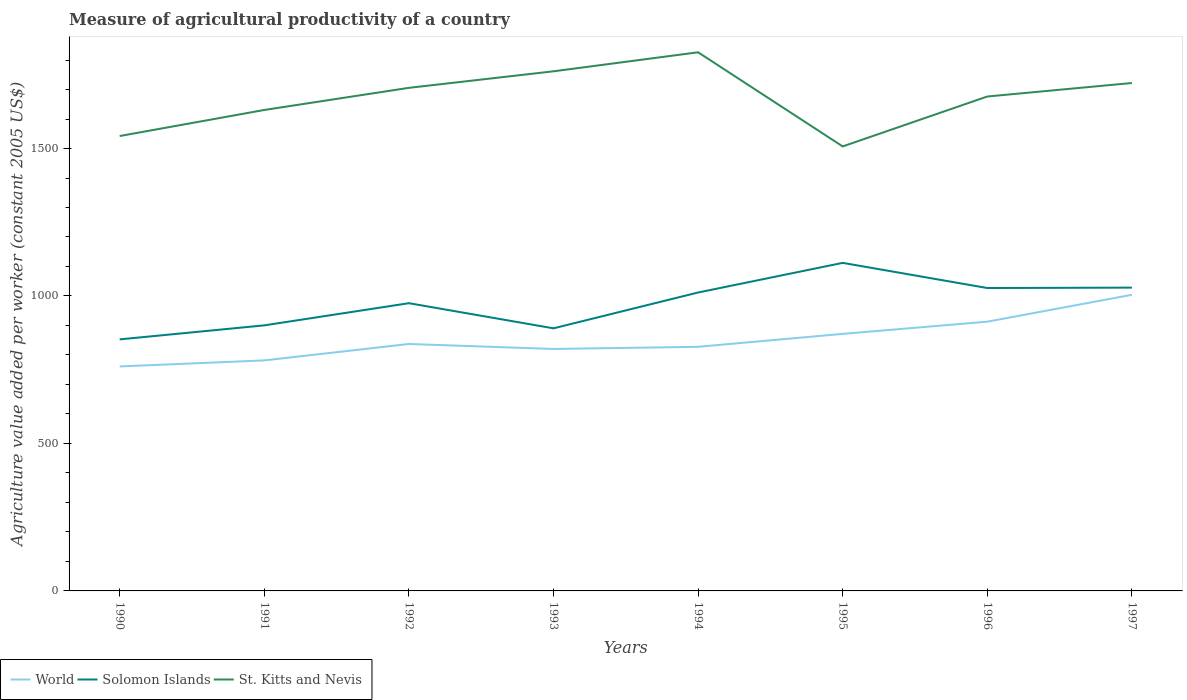How many different coloured lines are there?
Give a very brief answer. 3. Does the line corresponding to St. Kitts and Nevis intersect with the line corresponding to Solomon Islands?
Your answer should be compact. No. Across all years, what is the maximum measure of agricultural productivity in St. Kitts and Nevis?
Offer a terse response. 1507.05. What is the total measure of agricultural productivity in St. Kitts and Nevis in the graph?
Your answer should be very brief. -195.57. What is the difference between the highest and the second highest measure of agricultural productivity in Solomon Islands?
Give a very brief answer. 259.42. How many years are there in the graph?
Offer a terse response. 8. Are the values on the major ticks of Y-axis written in scientific E-notation?
Your answer should be very brief. No. Does the graph contain any zero values?
Offer a terse response. No. Does the graph contain grids?
Your answer should be very brief. No. What is the title of the graph?
Make the answer very short. Measure of agricultural productivity of a country. What is the label or title of the X-axis?
Keep it short and to the point. Years. What is the label or title of the Y-axis?
Keep it short and to the point. Agriculture value added per worker (constant 2005 US$). What is the Agriculture value added per worker (constant 2005 US$) in World in 1990?
Offer a very short reply. 761.04. What is the Agriculture value added per worker (constant 2005 US$) of Solomon Islands in 1990?
Keep it short and to the point. 852.86. What is the Agriculture value added per worker (constant 2005 US$) in St. Kitts and Nevis in 1990?
Your response must be concise. 1542.29. What is the Agriculture value added per worker (constant 2005 US$) of World in 1991?
Give a very brief answer. 781.57. What is the Agriculture value added per worker (constant 2005 US$) of Solomon Islands in 1991?
Your response must be concise. 900.38. What is the Agriculture value added per worker (constant 2005 US$) in St. Kitts and Nevis in 1991?
Offer a terse response. 1630.67. What is the Agriculture value added per worker (constant 2005 US$) in World in 1992?
Offer a very short reply. 837.24. What is the Agriculture value added per worker (constant 2005 US$) of Solomon Islands in 1992?
Your answer should be very brief. 975.54. What is the Agriculture value added per worker (constant 2005 US$) in St. Kitts and Nevis in 1992?
Your response must be concise. 1705.69. What is the Agriculture value added per worker (constant 2005 US$) of World in 1993?
Offer a very short reply. 820.33. What is the Agriculture value added per worker (constant 2005 US$) in Solomon Islands in 1993?
Make the answer very short. 890.33. What is the Agriculture value added per worker (constant 2005 US$) of St. Kitts and Nevis in 1993?
Make the answer very short. 1761.77. What is the Agriculture value added per worker (constant 2005 US$) in World in 1994?
Give a very brief answer. 827.67. What is the Agriculture value added per worker (constant 2005 US$) in Solomon Islands in 1994?
Give a very brief answer. 1011.77. What is the Agriculture value added per worker (constant 2005 US$) in St. Kitts and Nevis in 1994?
Keep it short and to the point. 1826.25. What is the Agriculture value added per worker (constant 2005 US$) in World in 1995?
Your answer should be very brief. 871.52. What is the Agriculture value added per worker (constant 2005 US$) of Solomon Islands in 1995?
Your answer should be compact. 1112.28. What is the Agriculture value added per worker (constant 2005 US$) of St. Kitts and Nevis in 1995?
Your answer should be very brief. 1507.05. What is the Agriculture value added per worker (constant 2005 US$) in World in 1996?
Offer a terse response. 912.86. What is the Agriculture value added per worker (constant 2005 US$) in Solomon Islands in 1996?
Offer a terse response. 1026.97. What is the Agriculture value added per worker (constant 2005 US$) of St. Kitts and Nevis in 1996?
Offer a very short reply. 1676.29. What is the Agriculture value added per worker (constant 2005 US$) of World in 1997?
Offer a terse response. 1003.99. What is the Agriculture value added per worker (constant 2005 US$) in Solomon Islands in 1997?
Give a very brief answer. 1028.33. What is the Agriculture value added per worker (constant 2005 US$) in St. Kitts and Nevis in 1997?
Give a very brief answer. 1722.06. Across all years, what is the maximum Agriculture value added per worker (constant 2005 US$) in World?
Provide a short and direct response. 1003.99. Across all years, what is the maximum Agriculture value added per worker (constant 2005 US$) in Solomon Islands?
Your response must be concise. 1112.28. Across all years, what is the maximum Agriculture value added per worker (constant 2005 US$) in St. Kitts and Nevis?
Your answer should be very brief. 1826.25. Across all years, what is the minimum Agriculture value added per worker (constant 2005 US$) in World?
Your response must be concise. 761.04. Across all years, what is the minimum Agriculture value added per worker (constant 2005 US$) of Solomon Islands?
Make the answer very short. 852.86. Across all years, what is the minimum Agriculture value added per worker (constant 2005 US$) in St. Kitts and Nevis?
Provide a succinct answer. 1507.05. What is the total Agriculture value added per worker (constant 2005 US$) in World in the graph?
Offer a very short reply. 6816.22. What is the total Agriculture value added per worker (constant 2005 US$) in Solomon Islands in the graph?
Provide a succinct answer. 7798.48. What is the total Agriculture value added per worker (constant 2005 US$) in St. Kitts and Nevis in the graph?
Give a very brief answer. 1.34e+04. What is the difference between the Agriculture value added per worker (constant 2005 US$) of World in 1990 and that in 1991?
Provide a succinct answer. -20.53. What is the difference between the Agriculture value added per worker (constant 2005 US$) in Solomon Islands in 1990 and that in 1991?
Keep it short and to the point. -47.52. What is the difference between the Agriculture value added per worker (constant 2005 US$) in St. Kitts and Nevis in 1990 and that in 1991?
Your response must be concise. -88.39. What is the difference between the Agriculture value added per worker (constant 2005 US$) in World in 1990 and that in 1992?
Give a very brief answer. -76.2. What is the difference between the Agriculture value added per worker (constant 2005 US$) in Solomon Islands in 1990 and that in 1992?
Offer a very short reply. -122.68. What is the difference between the Agriculture value added per worker (constant 2005 US$) in St. Kitts and Nevis in 1990 and that in 1992?
Ensure brevity in your answer.  -163.41. What is the difference between the Agriculture value added per worker (constant 2005 US$) of World in 1990 and that in 1993?
Provide a short and direct response. -59.29. What is the difference between the Agriculture value added per worker (constant 2005 US$) in Solomon Islands in 1990 and that in 1993?
Your response must be concise. -37.47. What is the difference between the Agriculture value added per worker (constant 2005 US$) in St. Kitts and Nevis in 1990 and that in 1993?
Provide a short and direct response. -219.48. What is the difference between the Agriculture value added per worker (constant 2005 US$) in World in 1990 and that in 1994?
Give a very brief answer. -66.63. What is the difference between the Agriculture value added per worker (constant 2005 US$) in Solomon Islands in 1990 and that in 1994?
Make the answer very short. -158.91. What is the difference between the Agriculture value added per worker (constant 2005 US$) of St. Kitts and Nevis in 1990 and that in 1994?
Ensure brevity in your answer.  -283.96. What is the difference between the Agriculture value added per worker (constant 2005 US$) of World in 1990 and that in 1995?
Give a very brief answer. -110.48. What is the difference between the Agriculture value added per worker (constant 2005 US$) of Solomon Islands in 1990 and that in 1995?
Provide a short and direct response. -259.42. What is the difference between the Agriculture value added per worker (constant 2005 US$) of St. Kitts and Nevis in 1990 and that in 1995?
Provide a succinct answer. 35.24. What is the difference between the Agriculture value added per worker (constant 2005 US$) in World in 1990 and that in 1996?
Your answer should be compact. -151.82. What is the difference between the Agriculture value added per worker (constant 2005 US$) in Solomon Islands in 1990 and that in 1996?
Provide a short and direct response. -174.11. What is the difference between the Agriculture value added per worker (constant 2005 US$) of St. Kitts and Nevis in 1990 and that in 1996?
Your answer should be very brief. -134.01. What is the difference between the Agriculture value added per worker (constant 2005 US$) in World in 1990 and that in 1997?
Offer a terse response. -242.95. What is the difference between the Agriculture value added per worker (constant 2005 US$) in Solomon Islands in 1990 and that in 1997?
Your response must be concise. -175.47. What is the difference between the Agriculture value added per worker (constant 2005 US$) of St. Kitts and Nevis in 1990 and that in 1997?
Your answer should be very brief. -179.78. What is the difference between the Agriculture value added per worker (constant 2005 US$) of World in 1991 and that in 1992?
Your answer should be very brief. -55.67. What is the difference between the Agriculture value added per worker (constant 2005 US$) in Solomon Islands in 1991 and that in 1992?
Make the answer very short. -75.16. What is the difference between the Agriculture value added per worker (constant 2005 US$) in St. Kitts and Nevis in 1991 and that in 1992?
Make the answer very short. -75.02. What is the difference between the Agriculture value added per worker (constant 2005 US$) of World in 1991 and that in 1993?
Give a very brief answer. -38.76. What is the difference between the Agriculture value added per worker (constant 2005 US$) of Solomon Islands in 1991 and that in 1993?
Provide a succinct answer. 10.05. What is the difference between the Agriculture value added per worker (constant 2005 US$) in St. Kitts and Nevis in 1991 and that in 1993?
Ensure brevity in your answer.  -131.1. What is the difference between the Agriculture value added per worker (constant 2005 US$) of World in 1991 and that in 1994?
Offer a terse response. -46.09. What is the difference between the Agriculture value added per worker (constant 2005 US$) in Solomon Islands in 1991 and that in 1994?
Provide a short and direct response. -111.39. What is the difference between the Agriculture value added per worker (constant 2005 US$) in St. Kitts and Nevis in 1991 and that in 1994?
Your answer should be compact. -195.57. What is the difference between the Agriculture value added per worker (constant 2005 US$) in World in 1991 and that in 1995?
Provide a succinct answer. -89.95. What is the difference between the Agriculture value added per worker (constant 2005 US$) of Solomon Islands in 1991 and that in 1995?
Offer a terse response. -211.9. What is the difference between the Agriculture value added per worker (constant 2005 US$) of St. Kitts and Nevis in 1991 and that in 1995?
Offer a terse response. 123.62. What is the difference between the Agriculture value added per worker (constant 2005 US$) in World in 1991 and that in 1996?
Keep it short and to the point. -131.29. What is the difference between the Agriculture value added per worker (constant 2005 US$) in Solomon Islands in 1991 and that in 1996?
Offer a very short reply. -126.59. What is the difference between the Agriculture value added per worker (constant 2005 US$) in St. Kitts and Nevis in 1991 and that in 1996?
Provide a short and direct response. -45.62. What is the difference between the Agriculture value added per worker (constant 2005 US$) of World in 1991 and that in 1997?
Keep it short and to the point. -222.42. What is the difference between the Agriculture value added per worker (constant 2005 US$) of Solomon Islands in 1991 and that in 1997?
Keep it short and to the point. -127.95. What is the difference between the Agriculture value added per worker (constant 2005 US$) in St. Kitts and Nevis in 1991 and that in 1997?
Offer a very short reply. -91.39. What is the difference between the Agriculture value added per worker (constant 2005 US$) in World in 1992 and that in 1993?
Give a very brief answer. 16.9. What is the difference between the Agriculture value added per worker (constant 2005 US$) in Solomon Islands in 1992 and that in 1993?
Your response must be concise. 85.21. What is the difference between the Agriculture value added per worker (constant 2005 US$) of St. Kitts and Nevis in 1992 and that in 1993?
Your response must be concise. -56.08. What is the difference between the Agriculture value added per worker (constant 2005 US$) in World in 1992 and that in 1994?
Your answer should be compact. 9.57. What is the difference between the Agriculture value added per worker (constant 2005 US$) of Solomon Islands in 1992 and that in 1994?
Your answer should be very brief. -36.23. What is the difference between the Agriculture value added per worker (constant 2005 US$) of St. Kitts and Nevis in 1992 and that in 1994?
Your answer should be compact. -120.55. What is the difference between the Agriculture value added per worker (constant 2005 US$) in World in 1992 and that in 1995?
Offer a very short reply. -34.28. What is the difference between the Agriculture value added per worker (constant 2005 US$) in Solomon Islands in 1992 and that in 1995?
Make the answer very short. -136.74. What is the difference between the Agriculture value added per worker (constant 2005 US$) in St. Kitts and Nevis in 1992 and that in 1995?
Your response must be concise. 198.64. What is the difference between the Agriculture value added per worker (constant 2005 US$) of World in 1992 and that in 1996?
Provide a succinct answer. -75.62. What is the difference between the Agriculture value added per worker (constant 2005 US$) in Solomon Islands in 1992 and that in 1996?
Make the answer very short. -51.43. What is the difference between the Agriculture value added per worker (constant 2005 US$) of St. Kitts and Nevis in 1992 and that in 1996?
Provide a short and direct response. 29.4. What is the difference between the Agriculture value added per worker (constant 2005 US$) in World in 1992 and that in 1997?
Ensure brevity in your answer.  -166.75. What is the difference between the Agriculture value added per worker (constant 2005 US$) in Solomon Islands in 1992 and that in 1997?
Your answer should be compact. -52.79. What is the difference between the Agriculture value added per worker (constant 2005 US$) of St. Kitts and Nevis in 1992 and that in 1997?
Your response must be concise. -16.37. What is the difference between the Agriculture value added per worker (constant 2005 US$) in World in 1993 and that in 1994?
Keep it short and to the point. -7.33. What is the difference between the Agriculture value added per worker (constant 2005 US$) in Solomon Islands in 1993 and that in 1994?
Give a very brief answer. -121.44. What is the difference between the Agriculture value added per worker (constant 2005 US$) in St. Kitts and Nevis in 1993 and that in 1994?
Keep it short and to the point. -64.47. What is the difference between the Agriculture value added per worker (constant 2005 US$) in World in 1993 and that in 1995?
Provide a short and direct response. -51.19. What is the difference between the Agriculture value added per worker (constant 2005 US$) in Solomon Islands in 1993 and that in 1995?
Your response must be concise. -221.95. What is the difference between the Agriculture value added per worker (constant 2005 US$) in St. Kitts and Nevis in 1993 and that in 1995?
Your response must be concise. 254.72. What is the difference between the Agriculture value added per worker (constant 2005 US$) in World in 1993 and that in 1996?
Offer a very short reply. -92.53. What is the difference between the Agriculture value added per worker (constant 2005 US$) of Solomon Islands in 1993 and that in 1996?
Your answer should be compact. -136.64. What is the difference between the Agriculture value added per worker (constant 2005 US$) of St. Kitts and Nevis in 1993 and that in 1996?
Offer a very short reply. 85.48. What is the difference between the Agriculture value added per worker (constant 2005 US$) in World in 1993 and that in 1997?
Make the answer very short. -183.65. What is the difference between the Agriculture value added per worker (constant 2005 US$) of Solomon Islands in 1993 and that in 1997?
Provide a succinct answer. -138. What is the difference between the Agriculture value added per worker (constant 2005 US$) of St. Kitts and Nevis in 1993 and that in 1997?
Your answer should be very brief. 39.71. What is the difference between the Agriculture value added per worker (constant 2005 US$) in World in 1994 and that in 1995?
Ensure brevity in your answer.  -43.86. What is the difference between the Agriculture value added per worker (constant 2005 US$) in Solomon Islands in 1994 and that in 1995?
Ensure brevity in your answer.  -100.51. What is the difference between the Agriculture value added per worker (constant 2005 US$) of St. Kitts and Nevis in 1994 and that in 1995?
Your answer should be very brief. 319.2. What is the difference between the Agriculture value added per worker (constant 2005 US$) in World in 1994 and that in 1996?
Give a very brief answer. -85.2. What is the difference between the Agriculture value added per worker (constant 2005 US$) in Solomon Islands in 1994 and that in 1996?
Offer a terse response. -15.2. What is the difference between the Agriculture value added per worker (constant 2005 US$) of St. Kitts and Nevis in 1994 and that in 1996?
Your answer should be very brief. 149.95. What is the difference between the Agriculture value added per worker (constant 2005 US$) of World in 1994 and that in 1997?
Make the answer very short. -176.32. What is the difference between the Agriculture value added per worker (constant 2005 US$) in Solomon Islands in 1994 and that in 1997?
Give a very brief answer. -16.56. What is the difference between the Agriculture value added per worker (constant 2005 US$) of St. Kitts and Nevis in 1994 and that in 1997?
Your response must be concise. 104.18. What is the difference between the Agriculture value added per worker (constant 2005 US$) of World in 1995 and that in 1996?
Your response must be concise. -41.34. What is the difference between the Agriculture value added per worker (constant 2005 US$) in Solomon Islands in 1995 and that in 1996?
Keep it short and to the point. 85.31. What is the difference between the Agriculture value added per worker (constant 2005 US$) in St. Kitts and Nevis in 1995 and that in 1996?
Provide a short and direct response. -169.24. What is the difference between the Agriculture value added per worker (constant 2005 US$) in World in 1995 and that in 1997?
Offer a very short reply. -132.47. What is the difference between the Agriculture value added per worker (constant 2005 US$) of Solomon Islands in 1995 and that in 1997?
Offer a very short reply. 83.95. What is the difference between the Agriculture value added per worker (constant 2005 US$) in St. Kitts and Nevis in 1995 and that in 1997?
Provide a succinct answer. -215.01. What is the difference between the Agriculture value added per worker (constant 2005 US$) of World in 1996 and that in 1997?
Ensure brevity in your answer.  -91.13. What is the difference between the Agriculture value added per worker (constant 2005 US$) in Solomon Islands in 1996 and that in 1997?
Provide a short and direct response. -1.36. What is the difference between the Agriculture value added per worker (constant 2005 US$) in St. Kitts and Nevis in 1996 and that in 1997?
Provide a succinct answer. -45.77. What is the difference between the Agriculture value added per worker (constant 2005 US$) in World in 1990 and the Agriculture value added per worker (constant 2005 US$) in Solomon Islands in 1991?
Ensure brevity in your answer.  -139.35. What is the difference between the Agriculture value added per worker (constant 2005 US$) in World in 1990 and the Agriculture value added per worker (constant 2005 US$) in St. Kitts and Nevis in 1991?
Offer a terse response. -869.63. What is the difference between the Agriculture value added per worker (constant 2005 US$) of Solomon Islands in 1990 and the Agriculture value added per worker (constant 2005 US$) of St. Kitts and Nevis in 1991?
Keep it short and to the point. -777.81. What is the difference between the Agriculture value added per worker (constant 2005 US$) in World in 1990 and the Agriculture value added per worker (constant 2005 US$) in Solomon Islands in 1992?
Make the answer very short. -214.5. What is the difference between the Agriculture value added per worker (constant 2005 US$) of World in 1990 and the Agriculture value added per worker (constant 2005 US$) of St. Kitts and Nevis in 1992?
Provide a short and direct response. -944.65. What is the difference between the Agriculture value added per worker (constant 2005 US$) in Solomon Islands in 1990 and the Agriculture value added per worker (constant 2005 US$) in St. Kitts and Nevis in 1992?
Your response must be concise. -852.83. What is the difference between the Agriculture value added per worker (constant 2005 US$) of World in 1990 and the Agriculture value added per worker (constant 2005 US$) of Solomon Islands in 1993?
Ensure brevity in your answer.  -129.29. What is the difference between the Agriculture value added per worker (constant 2005 US$) of World in 1990 and the Agriculture value added per worker (constant 2005 US$) of St. Kitts and Nevis in 1993?
Your answer should be very brief. -1000.73. What is the difference between the Agriculture value added per worker (constant 2005 US$) of Solomon Islands in 1990 and the Agriculture value added per worker (constant 2005 US$) of St. Kitts and Nevis in 1993?
Provide a short and direct response. -908.91. What is the difference between the Agriculture value added per worker (constant 2005 US$) of World in 1990 and the Agriculture value added per worker (constant 2005 US$) of Solomon Islands in 1994?
Give a very brief answer. -250.73. What is the difference between the Agriculture value added per worker (constant 2005 US$) in World in 1990 and the Agriculture value added per worker (constant 2005 US$) in St. Kitts and Nevis in 1994?
Provide a succinct answer. -1065.21. What is the difference between the Agriculture value added per worker (constant 2005 US$) of Solomon Islands in 1990 and the Agriculture value added per worker (constant 2005 US$) of St. Kitts and Nevis in 1994?
Ensure brevity in your answer.  -973.38. What is the difference between the Agriculture value added per worker (constant 2005 US$) of World in 1990 and the Agriculture value added per worker (constant 2005 US$) of Solomon Islands in 1995?
Provide a succinct answer. -351.24. What is the difference between the Agriculture value added per worker (constant 2005 US$) of World in 1990 and the Agriculture value added per worker (constant 2005 US$) of St. Kitts and Nevis in 1995?
Give a very brief answer. -746.01. What is the difference between the Agriculture value added per worker (constant 2005 US$) in Solomon Islands in 1990 and the Agriculture value added per worker (constant 2005 US$) in St. Kitts and Nevis in 1995?
Provide a short and direct response. -654.19. What is the difference between the Agriculture value added per worker (constant 2005 US$) of World in 1990 and the Agriculture value added per worker (constant 2005 US$) of Solomon Islands in 1996?
Your answer should be compact. -265.93. What is the difference between the Agriculture value added per worker (constant 2005 US$) of World in 1990 and the Agriculture value added per worker (constant 2005 US$) of St. Kitts and Nevis in 1996?
Keep it short and to the point. -915.25. What is the difference between the Agriculture value added per worker (constant 2005 US$) of Solomon Islands in 1990 and the Agriculture value added per worker (constant 2005 US$) of St. Kitts and Nevis in 1996?
Your answer should be very brief. -823.43. What is the difference between the Agriculture value added per worker (constant 2005 US$) in World in 1990 and the Agriculture value added per worker (constant 2005 US$) in Solomon Islands in 1997?
Provide a succinct answer. -267.29. What is the difference between the Agriculture value added per worker (constant 2005 US$) in World in 1990 and the Agriculture value added per worker (constant 2005 US$) in St. Kitts and Nevis in 1997?
Provide a succinct answer. -961.02. What is the difference between the Agriculture value added per worker (constant 2005 US$) in Solomon Islands in 1990 and the Agriculture value added per worker (constant 2005 US$) in St. Kitts and Nevis in 1997?
Provide a succinct answer. -869.2. What is the difference between the Agriculture value added per worker (constant 2005 US$) in World in 1991 and the Agriculture value added per worker (constant 2005 US$) in Solomon Islands in 1992?
Offer a very short reply. -193.97. What is the difference between the Agriculture value added per worker (constant 2005 US$) of World in 1991 and the Agriculture value added per worker (constant 2005 US$) of St. Kitts and Nevis in 1992?
Ensure brevity in your answer.  -924.12. What is the difference between the Agriculture value added per worker (constant 2005 US$) in Solomon Islands in 1991 and the Agriculture value added per worker (constant 2005 US$) in St. Kitts and Nevis in 1992?
Ensure brevity in your answer.  -805.31. What is the difference between the Agriculture value added per worker (constant 2005 US$) of World in 1991 and the Agriculture value added per worker (constant 2005 US$) of Solomon Islands in 1993?
Your answer should be compact. -108.76. What is the difference between the Agriculture value added per worker (constant 2005 US$) of World in 1991 and the Agriculture value added per worker (constant 2005 US$) of St. Kitts and Nevis in 1993?
Offer a very short reply. -980.2. What is the difference between the Agriculture value added per worker (constant 2005 US$) of Solomon Islands in 1991 and the Agriculture value added per worker (constant 2005 US$) of St. Kitts and Nevis in 1993?
Make the answer very short. -861.39. What is the difference between the Agriculture value added per worker (constant 2005 US$) of World in 1991 and the Agriculture value added per worker (constant 2005 US$) of Solomon Islands in 1994?
Offer a very short reply. -230.2. What is the difference between the Agriculture value added per worker (constant 2005 US$) of World in 1991 and the Agriculture value added per worker (constant 2005 US$) of St. Kitts and Nevis in 1994?
Give a very brief answer. -1044.67. What is the difference between the Agriculture value added per worker (constant 2005 US$) in Solomon Islands in 1991 and the Agriculture value added per worker (constant 2005 US$) in St. Kitts and Nevis in 1994?
Make the answer very short. -925.86. What is the difference between the Agriculture value added per worker (constant 2005 US$) in World in 1991 and the Agriculture value added per worker (constant 2005 US$) in Solomon Islands in 1995?
Your response must be concise. -330.71. What is the difference between the Agriculture value added per worker (constant 2005 US$) of World in 1991 and the Agriculture value added per worker (constant 2005 US$) of St. Kitts and Nevis in 1995?
Your response must be concise. -725.48. What is the difference between the Agriculture value added per worker (constant 2005 US$) in Solomon Islands in 1991 and the Agriculture value added per worker (constant 2005 US$) in St. Kitts and Nevis in 1995?
Your answer should be very brief. -606.66. What is the difference between the Agriculture value added per worker (constant 2005 US$) of World in 1991 and the Agriculture value added per worker (constant 2005 US$) of Solomon Islands in 1996?
Provide a succinct answer. -245.4. What is the difference between the Agriculture value added per worker (constant 2005 US$) in World in 1991 and the Agriculture value added per worker (constant 2005 US$) in St. Kitts and Nevis in 1996?
Ensure brevity in your answer.  -894.72. What is the difference between the Agriculture value added per worker (constant 2005 US$) in Solomon Islands in 1991 and the Agriculture value added per worker (constant 2005 US$) in St. Kitts and Nevis in 1996?
Ensure brevity in your answer.  -775.91. What is the difference between the Agriculture value added per worker (constant 2005 US$) in World in 1991 and the Agriculture value added per worker (constant 2005 US$) in Solomon Islands in 1997?
Offer a very short reply. -246.76. What is the difference between the Agriculture value added per worker (constant 2005 US$) of World in 1991 and the Agriculture value added per worker (constant 2005 US$) of St. Kitts and Nevis in 1997?
Provide a short and direct response. -940.49. What is the difference between the Agriculture value added per worker (constant 2005 US$) in Solomon Islands in 1991 and the Agriculture value added per worker (constant 2005 US$) in St. Kitts and Nevis in 1997?
Ensure brevity in your answer.  -821.68. What is the difference between the Agriculture value added per worker (constant 2005 US$) of World in 1992 and the Agriculture value added per worker (constant 2005 US$) of Solomon Islands in 1993?
Provide a short and direct response. -53.1. What is the difference between the Agriculture value added per worker (constant 2005 US$) in World in 1992 and the Agriculture value added per worker (constant 2005 US$) in St. Kitts and Nevis in 1993?
Provide a succinct answer. -924.53. What is the difference between the Agriculture value added per worker (constant 2005 US$) of Solomon Islands in 1992 and the Agriculture value added per worker (constant 2005 US$) of St. Kitts and Nevis in 1993?
Your answer should be very brief. -786.23. What is the difference between the Agriculture value added per worker (constant 2005 US$) of World in 1992 and the Agriculture value added per worker (constant 2005 US$) of Solomon Islands in 1994?
Ensure brevity in your answer.  -174.53. What is the difference between the Agriculture value added per worker (constant 2005 US$) in World in 1992 and the Agriculture value added per worker (constant 2005 US$) in St. Kitts and Nevis in 1994?
Your answer should be very brief. -989.01. What is the difference between the Agriculture value added per worker (constant 2005 US$) in Solomon Islands in 1992 and the Agriculture value added per worker (constant 2005 US$) in St. Kitts and Nevis in 1994?
Your response must be concise. -850.71. What is the difference between the Agriculture value added per worker (constant 2005 US$) of World in 1992 and the Agriculture value added per worker (constant 2005 US$) of Solomon Islands in 1995?
Make the answer very short. -275.04. What is the difference between the Agriculture value added per worker (constant 2005 US$) in World in 1992 and the Agriculture value added per worker (constant 2005 US$) in St. Kitts and Nevis in 1995?
Make the answer very short. -669.81. What is the difference between the Agriculture value added per worker (constant 2005 US$) of Solomon Islands in 1992 and the Agriculture value added per worker (constant 2005 US$) of St. Kitts and Nevis in 1995?
Provide a short and direct response. -531.51. What is the difference between the Agriculture value added per worker (constant 2005 US$) in World in 1992 and the Agriculture value added per worker (constant 2005 US$) in Solomon Islands in 1996?
Provide a succinct answer. -189.74. What is the difference between the Agriculture value added per worker (constant 2005 US$) in World in 1992 and the Agriculture value added per worker (constant 2005 US$) in St. Kitts and Nevis in 1996?
Your answer should be compact. -839.05. What is the difference between the Agriculture value added per worker (constant 2005 US$) of Solomon Islands in 1992 and the Agriculture value added per worker (constant 2005 US$) of St. Kitts and Nevis in 1996?
Offer a very short reply. -700.75. What is the difference between the Agriculture value added per worker (constant 2005 US$) in World in 1992 and the Agriculture value added per worker (constant 2005 US$) in Solomon Islands in 1997?
Your answer should be compact. -191.1. What is the difference between the Agriculture value added per worker (constant 2005 US$) of World in 1992 and the Agriculture value added per worker (constant 2005 US$) of St. Kitts and Nevis in 1997?
Give a very brief answer. -884.82. What is the difference between the Agriculture value added per worker (constant 2005 US$) in Solomon Islands in 1992 and the Agriculture value added per worker (constant 2005 US$) in St. Kitts and Nevis in 1997?
Your answer should be very brief. -746.52. What is the difference between the Agriculture value added per worker (constant 2005 US$) of World in 1993 and the Agriculture value added per worker (constant 2005 US$) of Solomon Islands in 1994?
Give a very brief answer. -191.44. What is the difference between the Agriculture value added per worker (constant 2005 US$) of World in 1993 and the Agriculture value added per worker (constant 2005 US$) of St. Kitts and Nevis in 1994?
Your response must be concise. -1005.91. What is the difference between the Agriculture value added per worker (constant 2005 US$) of Solomon Islands in 1993 and the Agriculture value added per worker (constant 2005 US$) of St. Kitts and Nevis in 1994?
Provide a succinct answer. -935.91. What is the difference between the Agriculture value added per worker (constant 2005 US$) in World in 1993 and the Agriculture value added per worker (constant 2005 US$) in Solomon Islands in 1995?
Your answer should be compact. -291.95. What is the difference between the Agriculture value added per worker (constant 2005 US$) in World in 1993 and the Agriculture value added per worker (constant 2005 US$) in St. Kitts and Nevis in 1995?
Keep it short and to the point. -686.72. What is the difference between the Agriculture value added per worker (constant 2005 US$) of Solomon Islands in 1993 and the Agriculture value added per worker (constant 2005 US$) of St. Kitts and Nevis in 1995?
Offer a terse response. -616.72. What is the difference between the Agriculture value added per worker (constant 2005 US$) in World in 1993 and the Agriculture value added per worker (constant 2005 US$) in Solomon Islands in 1996?
Your response must be concise. -206.64. What is the difference between the Agriculture value added per worker (constant 2005 US$) of World in 1993 and the Agriculture value added per worker (constant 2005 US$) of St. Kitts and Nevis in 1996?
Give a very brief answer. -855.96. What is the difference between the Agriculture value added per worker (constant 2005 US$) in Solomon Islands in 1993 and the Agriculture value added per worker (constant 2005 US$) in St. Kitts and Nevis in 1996?
Provide a short and direct response. -785.96. What is the difference between the Agriculture value added per worker (constant 2005 US$) in World in 1993 and the Agriculture value added per worker (constant 2005 US$) in Solomon Islands in 1997?
Give a very brief answer. -208. What is the difference between the Agriculture value added per worker (constant 2005 US$) of World in 1993 and the Agriculture value added per worker (constant 2005 US$) of St. Kitts and Nevis in 1997?
Your response must be concise. -901.73. What is the difference between the Agriculture value added per worker (constant 2005 US$) of Solomon Islands in 1993 and the Agriculture value added per worker (constant 2005 US$) of St. Kitts and Nevis in 1997?
Ensure brevity in your answer.  -831.73. What is the difference between the Agriculture value added per worker (constant 2005 US$) of World in 1994 and the Agriculture value added per worker (constant 2005 US$) of Solomon Islands in 1995?
Your response must be concise. -284.61. What is the difference between the Agriculture value added per worker (constant 2005 US$) in World in 1994 and the Agriculture value added per worker (constant 2005 US$) in St. Kitts and Nevis in 1995?
Your answer should be very brief. -679.38. What is the difference between the Agriculture value added per worker (constant 2005 US$) in Solomon Islands in 1994 and the Agriculture value added per worker (constant 2005 US$) in St. Kitts and Nevis in 1995?
Make the answer very short. -495.28. What is the difference between the Agriculture value added per worker (constant 2005 US$) in World in 1994 and the Agriculture value added per worker (constant 2005 US$) in Solomon Islands in 1996?
Your answer should be compact. -199.31. What is the difference between the Agriculture value added per worker (constant 2005 US$) in World in 1994 and the Agriculture value added per worker (constant 2005 US$) in St. Kitts and Nevis in 1996?
Ensure brevity in your answer.  -848.63. What is the difference between the Agriculture value added per worker (constant 2005 US$) in Solomon Islands in 1994 and the Agriculture value added per worker (constant 2005 US$) in St. Kitts and Nevis in 1996?
Make the answer very short. -664.52. What is the difference between the Agriculture value added per worker (constant 2005 US$) in World in 1994 and the Agriculture value added per worker (constant 2005 US$) in Solomon Islands in 1997?
Make the answer very short. -200.67. What is the difference between the Agriculture value added per worker (constant 2005 US$) in World in 1994 and the Agriculture value added per worker (constant 2005 US$) in St. Kitts and Nevis in 1997?
Your response must be concise. -894.4. What is the difference between the Agriculture value added per worker (constant 2005 US$) of Solomon Islands in 1994 and the Agriculture value added per worker (constant 2005 US$) of St. Kitts and Nevis in 1997?
Your answer should be compact. -710.29. What is the difference between the Agriculture value added per worker (constant 2005 US$) in World in 1995 and the Agriculture value added per worker (constant 2005 US$) in Solomon Islands in 1996?
Provide a succinct answer. -155.45. What is the difference between the Agriculture value added per worker (constant 2005 US$) in World in 1995 and the Agriculture value added per worker (constant 2005 US$) in St. Kitts and Nevis in 1996?
Offer a terse response. -804.77. What is the difference between the Agriculture value added per worker (constant 2005 US$) in Solomon Islands in 1995 and the Agriculture value added per worker (constant 2005 US$) in St. Kitts and Nevis in 1996?
Give a very brief answer. -564.01. What is the difference between the Agriculture value added per worker (constant 2005 US$) in World in 1995 and the Agriculture value added per worker (constant 2005 US$) in Solomon Islands in 1997?
Make the answer very short. -156.81. What is the difference between the Agriculture value added per worker (constant 2005 US$) in World in 1995 and the Agriculture value added per worker (constant 2005 US$) in St. Kitts and Nevis in 1997?
Provide a succinct answer. -850.54. What is the difference between the Agriculture value added per worker (constant 2005 US$) of Solomon Islands in 1995 and the Agriculture value added per worker (constant 2005 US$) of St. Kitts and Nevis in 1997?
Offer a very short reply. -609.78. What is the difference between the Agriculture value added per worker (constant 2005 US$) in World in 1996 and the Agriculture value added per worker (constant 2005 US$) in Solomon Islands in 1997?
Keep it short and to the point. -115.47. What is the difference between the Agriculture value added per worker (constant 2005 US$) in World in 1996 and the Agriculture value added per worker (constant 2005 US$) in St. Kitts and Nevis in 1997?
Give a very brief answer. -809.2. What is the difference between the Agriculture value added per worker (constant 2005 US$) of Solomon Islands in 1996 and the Agriculture value added per worker (constant 2005 US$) of St. Kitts and Nevis in 1997?
Make the answer very short. -695.09. What is the average Agriculture value added per worker (constant 2005 US$) in World per year?
Provide a succinct answer. 852.03. What is the average Agriculture value added per worker (constant 2005 US$) in Solomon Islands per year?
Give a very brief answer. 974.81. What is the average Agriculture value added per worker (constant 2005 US$) in St. Kitts and Nevis per year?
Offer a terse response. 1671.51. In the year 1990, what is the difference between the Agriculture value added per worker (constant 2005 US$) in World and Agriculture value added per worker (constant 2005 US$) in Solomon Islands?
Make the answer very short. -91.82. In the year 1990, what is the difference between the Agriculture value added per worker (constant 2005 US$) of World and Agriculture value added per worker (constant 2005 US$) of St. Kitts and Nevis?
Your answer should be compact. -781.25. In the year 1990, what is the difference between the Agriculture value added per worker (constant 2005 US$) of Solomon Islands and Agriculture value added per worker (constant 2005 US$) of St. Kitts and Nevis?
Provide a short and direct response. -689.42. In the year 1991, what is the difference between the Agriculture value added per worker (constant 2005 US$) in World and Agriculture value added per worker (constant 2005 US$) in Solomon Islands?
Provide a succinct answer. -118.81. In the year 1991, what is the difference between the Agriculture value added per worker (constant 2005 US$) of World and Agriculture value added per worker (constant 2005 US$) of St. Kitts and Nevis?
Give a very brief answer. -849.1. In the year 1991, what is the difference between the Agriculture value added per worker (constant 2005 US$) in Solomon Islands and Agriculture value added per worker (constant 2005 US$) in St. Kitts and Nevis?
Provide a short and direct response. -730.29. In the year 1992, what is the difference between the Agriculture value added per worker (constant 2005 US$) of World and Agriculture value added per worker (constant 2005 US$) of Solomon Islands?
Provide a short and direct response. -138.3. In the year 1992, what is the difference between the Agriculture value added per worker (constant 2005 US$) of World and Agriculture value added per worker (constant 2005 US$) of St. Kitts and Nevis?
Make the answer very short. -868.46. In the year 1992, what is the difference between the Agriculture value added per worker (constant 2005 US$) of Solomon Islands and Agriculture value added per worker (constant 2005 US$) of St. Kitts and Nevis?
Provide a succinct answer. -730.15. In the year 1993, what is the difference between the Agriculture value added per worker (constant 2005 US$) in World and Agriculture value added per worker (constant 2005 US$) in Solomon Islands?
Offer a terse response. -70. In the year 1993, what is the difference between the Agriculture value added per worker (constant 2005 US$) of World and Agriculture value added per worker (constant 2005 US$) of St. Kitts and Nevis?
Offer a very short reply. -941.44. In the year 1993, what is the difference between the Agriculture value added per worker (constant 2005 US$) in Solomon Islands and Agriculture value added per worker (constant 2005 US$) in St. Kitts and Nevis?
Your response must be concise. -871.44. In the year 1994, what is the difference between the Agriculture value added per worker (constant 2005 US$) of World and Agriculture value added per worker (constant 2005 US$) of Solomon Islands?
Provide a short and direct response. -184.1. In the year 1994, what is the difference between the Agriculture value added per worker (constant 2005 US$) of World and Agriculture value added per worker (constant 2005 US$) of St. Kitts and Nevis?
Your answer should be compact. -998.58. In the year 1994, what is the difference between the Agriculture value added per worker (constant 2005 US$) of Solomon Islands and Agriculture value added per worker (constant 2005 US$) of St. Kitts and Nevis?
Provide a succinct answer. -814.47. In the year 1995, what is the difference between the Agriculture value added per worker (constant 2005 US$) in World and Agriculture value added per worker (constant 2005 US$) in Solomon Islands?
Your response must be concise. -240.76. In the year 1995, what is the difference between the Agriculture value added per worker (constant 2005 US$) of World and Agriculture value added per worker (constant 2005 US$) of St. Kitts and Nevis?
Keep it short and to the point. -635.53. In the year 1995, what is the difference between the Agriculture value added per worker (constant 2005 US$) in Solomon Islands and Agriculture value added per worker (constant 2005 US$) in St. Kitts and Nevis?
Give a very brief answer. -394.77. In the year 1996, what is the difference between the Agriculture value added per worker (constant 2005 US$) of World and Agriculture value added per worker (constant 2005 US$) of Solomon Islands?
Ensure brevity in your answer.  -114.11. In the year 1996, what is the difference between the Agriculture value added per worker (constant 2005 US$) in World and Agriculture value added per worker (constant 2005 US$) in St. Kitts and Nevis?
Give a very brief answer. -763.43. In the year 1996, what is the difference between the Agriculture value added per worker (constant 2005 US$) in Solomon Islands and Agriculture value added per worker (constant 2005 US$) in St. Kitts and Nevis?
Offer a very short reply. -649.32. In the year 1997, what is the difference between the Agriculture value added per worker (constant 2005 US$) in World and Agriculture value added per worker (constant 2005 US$) in Solomon Islands?
Your answer should be very brief. -24.35. In the year 1997, what is the difference between the Agriculture value added per worker (constant 2005 US$) of World and Agriculture value added per worker (constant 2005 US$) of St. Kitts and Nevis?
Provide a succinct answer. -718.07. In the year 1997, what is the difference between the Agriculture value added per worker (constant 2005 US$) of Solomon Islands and Agriculture value added per worker (constant 2005 US$) of St. Kitts and Nevis?
Ensure brevity in your answer.  -693.73. What is the ratio of the Agriculture value added per worker (constant 2005 US$) of World in 1990 to that in 1991?
Make the answer very short. 0.97. What is the ratio of the Agriculture value added per worker (constant 2005 US$) in Solomon Islands in 1990 to that in 1991?
Offer a very short reply. 0.95. What is the ratio of the Agriculture value added per worker (constant 2005 US$) of St. Kitts and Nevis in 1990 to that in 1991?
Your answer should be compact. 0.95. What is the ratio of the Agriculture value added per worker (constant 2005 US$) of World in 1990 to that in 1992?
Give a very brief answer. 0.91. What is the ratio of the Agriculture value added per worker (constant 2005 US$) of Solomon Islands in 1990 to that in 1992?
Keep it short and to the point. 0.87. What is the ratio of the Agriculture value added per worker (constant 2005 US$) in St. Kitts and Nevis in 1990 to that in 1992?
Provide a succinct answer. 0.9. What is the ratio of the Agriculture value added per worker (constant 2005 US$) of World in 1990 to that in 1993?
Offer a very short reply. 0.93. What is the ratio of the Agriculture value added per worker (constant 2005 US$) in Solomon Islands in 1990 to that in 1993?
Keep it short and to the point. 0.96. What is the ratio of the Agriculture value added per worker (constant 2005 US$) of St. Kitts and Nevis in 1990 to that in 1993?
Your answer should be compact. 0.88. What is the ratio of the Agriculture value added per worker (constant 2005 US$) of World in 1990 to that in 1994?
Offer a very short reply. 0.92. What is the ratio of the Agriculture value added per worker (constant 2005 US$) of Solomon Islands in 1990 to that in 1994?
Make the answer very short. 0.84. What is the ratio of the Agriculture value added per worker (constant 2005 US$) in St. Kitts and Nevis in 1990 to that in 1994?
Your answer should be very brief. 0.84. What is the ratio of the Agriculture value added per worker (constant 2005 US$) in World in 1990 to that in 1995?
Make the answer very short. 0.87. What is the ratio of the Agriculture value added per worker (constant 2005 US$) in Solomon Islands in 1990 to that in 1995?
Offer a very short reply. 0.77. What is the ratio of the Agriculture value added per worker (constant 2005 US$) in St. Kitts and Nevis in 1990 to that in 1995?
Give a very brief answer. 1.02. What is the ratio of the Agriculture value added per worker (constant 2005 US$) in World in 1990 to that in 1996?
Your answer should be very brief. 0.83. What is the ratio of the Agriculture value added per worker (constant 2005 US$) of Solomon Islands in 1990 to that in 1996?
Keep it short and to the point. 0.83. What is the ratio of the Agriculture value added per worker (constant 2005 US$) of St. Kitts and Nevis in 1990 to that in 1996?
Keep it short and to the point. 0.92. What is the ratio of the Agriculture value added per worker (constant 2005 US$) of World in 1990 to that in 1997?
Offer a terse response. 0.76. What is the ratio of the Agriculture value added per worker (constant 2005 US$) of Solomon Islands in 1990 to that in 1997?
Ensure brevity in your answer.  0.83. What is the ratio of the Agriculture value added per worker (constant 2005 US$) in St. Kitts and Nevis in 1990 to that in 1997?
Make the answer very short. 0.9. What is the ratio of the Agriculture value added per worker (constant 2005 US$) of World in 1991 to that in 1992?
Provide a short and direct response. 0.93. What is the ratio of the Agriculture value added per worker (constant 2005 US$) of Solomon Islands in 1991 to that in 1992?
Your answer should be compact. 0.92. What is the ratio of the Agriculture value added per worker (constant 2005 US$) of St. Kitts and Nevis in 1991 to that in 1992?
Offer a terse response. 0.96. What is the ratio of the Agriculture value added per worker (constant 2005 US$) of World in 1991 to that in 1993?
Keep it short and to the point. 0.95. What is the ratio of the Agriculture value added per worker (constant 2005 US$) in Solomon Islands in 1991 to that in 1993?
Offer a terse response. 1.01. What is the ratio of the Agriculture value added per worker (constant 2005 US$) of St. Kitts and Nevis in 1991 to that in 1993?
Ensure brevity in your answer.  0.93. What is the ratio of the Agriculture value added per worker (constant 2005 US$) of World in 1991 to that in 1994?
Provide a succinct answer. 0.94. What is the ratio of the Agriculture value added per worker (constant 2005 US$) of Solomon Islands in 1991 to that in 1994?
Your answer should be compact. 0.89. What is the ratio of the Agriculture value added per worker (constant 2005 US$) in St. Kitts and Nevis in 1991 to that in 1994?
Your response must be concise. 0.89. What is the ratio of the Agriculture value added per worker (constant 2005 US$) of World in 1991 to that in 1995?
Your answer should be very brief. 0.9. What is the ratio of the Agriculture value added per worker (constant 2005 US$) of Solomon Islands in 1991 to that in 1995?
Give a very brief answer. 0.81. What is the ratio of the Agriculture value added per worker (constant 2005 US$) in St. Kitts and Nevis in 1991 to that in 1995?
Ensure brevity in your answer.  1.08. What is the ratio of the Agriculture value added per worker (constant 2005 US$) in World in 1991 to that in 1996?
Provide a succinct answer. 0.86. What is the ratio of the Agriculture value added per worker (constant 2005 US$) in Solomon Islands in 1991 to that in 1996?
Provide a succinct answer. 0.88. What is the ratio of the Agriculture value added per worker (constant 2005 US$) of St. Kitts and Nevis in 1991 to that in 1996?
Offer a terse response. 0.97. What is the ratio of the Agriculture value added per worker (constant 2005 US$) in World in 1991 to that in 1997?
Keep it short and to the point. 0.78. What is the ratio of the Agriculture value added per worker (constant 2005 US$) of Solomon Islands in 1991 to that in 1997?
Provide a succinct answer. 0.88. What is the ratio of the Agriculture value added per worker (constant 2005 US$) in St. Kitts and Nevis in 1991 to that in 1997?
Keep it short and to the point. 0.95. What is the ratio of the Agriculture value added per worker (constant 2005 US$) in World in 1992 to that in 1993?
Offer a very short reply. 1.02. What is the ratio of the Agriculture value added per worker (constant 2005 US$) of Solomon Islands in 1992 to that in 1993?
Give a very brief answer. 1.1. What is the ratio of the Agriculture value added per worker (constant 2005 US$) of St. Kitts and Nevis in 1992 to that in 1993?
Provide a short and direct response. 0.97. What is the ratio of the Agriculture value added per worker (constant 2005 US$) in World in 1992 to that in 1994?
Keep it short and to the point. 1.01. What is the ratio of the Agriculture value added per worker (constant 2005 US$) in Solomon Islands in 1992 to that in 1994?
Your response must be concise. 0.96. What is the ratio of the Agriculture value added per worker (constant 2005 US$) of St. Kitts and Nevis in 1992 to that in 1994?
Provide a succinct answer. 0.93. What is the ratio of the Agriculture value added per worker (constant 2005 US$) of World in 1992 to that in 1995?
Ensure brevity in your answer.  0.96. What is the ratio of the Agriculture value added per worker (constant 2005 US$) in Solomon Islands in 1992 to that in 1995?
Keep it short and to the point. 0.88. What is the ratio of the Agriculture value added per worker (constant 2005 US$) of St. Kitts and Nevis in 1992 to that in 1995?
Ensure brevity in your answer.  1.13. What is the ratio of the Agriculture value added per worker (constant 2005 US$) of World in 1992 to that in 1996?
Offer a very short reply. 0.92. What is the ratio of the Agriculture value added per worker (constant 2005 US$) of Solomon Islands in 1992 to that in 1996?
Your answer should be very brief. 0.95. What is the ratio of the Agriculture value added per worker (constant 2005 US$) in St. Kitts and Nevis in 1992 to that in 1996?
Ensure brevity in your answer.  1.02. What is the ratio of the Agriculture value added per worker (constant 2005 US$) in World in 1992 to that in 1997?
Offer a terse response. 0.83. What is the ratio of the Agriculture value added per worker (constant 2005 US$) of Solomon Islands in 1992 to that in 1997?
Your response must be concise. 0.95. What is the ratio of the Agriculture value added per worker (constant 2005 US$) in St. Kitts and Nevis in 1992 to that in 1997?
Provide a short and direct response. 0.99. What is the ratio of the Agriculture value added per worker (constant 2005 US$) of World in 1993 to that in 1994?
Your response must be concise. 0.99. What is the ratio of the Agriculture value added per worker (constant 2005 US$) of St. Kitts and Nevis in 1993 to that in 1994?
Your response must be concise. 0.96. What is the ratio of the Agriculture value added per worker (constant 2005 US$) of World in 1993 to that in 1995?
Give a very brief answer. 0.94. What is the ratio of the Agriculture value added per worker (constant 2005 US$) in Solomon Islands in 1993 to that in 1995?
Offer a very short reply. 0.8. What is the ratio of the Agriculture value added per worker (constant 2005 US$) of St. Kitts and Nevis in 1993 to that in 1995?
Your answer should be very brief. 1.17. What is the ratio of the Agriculture value added per worker (constant 2005 US$) of World in 1993 to that in 1996?
Your answer should be compact. 0.9. What is the ratio of the Agriculture value added per worker (constant 2005 US$) in Solomon Islands in 1993 to that in 1996?
Provide a short and direct response. 0.87. What is the ratio of the Agriculture value added per worker (constant 2005 US$) in St. Kitts and Nevis in 1993 to that in 1996?
Your answer should be very brief. 1.05. What is the ratio of the Agriculture value added per worker (constant 2005 US$) in World in 1993 to that in 1997?
Offer a very short reply. 0.82. What is the ratio of the Agriculture value added per worker (constant 2005 US$) in Solomon Islands in 1993 to that in 1997?
Provide a succinct answer. 0.87. What is the ratio of the Agriculture value added per worker (constant 2005 US$) of St. Kitts and Nevis in 1993 to that in 1997?
Keep it short and to the point. 1.02. What is the ratio of the Agriculture value added per worker (constant 2005 US$) of World in 1994 to that in 1995?
Make the answer very short. 0.95. What is the ratio of the Agriculture value added per worker (constant 2005 US$) of Solomon Islands in 1994 to that in 1995?
Your response must be concise. 0.91. What is the ratio of the Agriculture value added per worker (constant 2005 US$) in St. Kitts and Nevis in 1994 to that in 1995?
Your response must be concise. 1.21. What is the ratio of the Agriculture value added per worker (constant 2005 US$) of World in 1994 to that in 1996?
Ensure brevity in your answer.  0.91. What is the ratio of the Agriculture value added per worker (constant 2005 US$) of Solomon Islands in 1994 to that in 1996?
Offer a very short reply. 0.99. What is the ratio of the Agriculture value added per worker (constant 2005 US$) in St. Kitts and Nevis in 1994 to that in 1996?
Keep it short and to the point. 1.09. What is the ratio of the Agriculture value added per worker (constant 2005 US$) of World in 1994 to that in 1997?
Give a very brief answer. 0.82. What is the ratio of the Agriculture value added per worker (constant 2005 US$) in Solomon Islands in 1994 to that in 1997?
Offer a terse response. 0.98. What is the ratio of the Agriculture value added per worker (constant 2005 US$) in St. Kitts and Nevis in 1994 to that in 1997?
Ensure brevity in your answer.  1.06. What is the ratio of the Agriculture value added per worker (constant 2005 US$) in World in 1995 to that in 1996?
Give a very brief answer. 0.95. What is the ratio of the Agriculture value added per worker (constant 2005 US$) of Solomon Islands in 1995 to that in 1996?
Offer a very short reply. 1.08. What is the ratio of the Agriculture value added per worker (constant 2005 US$) of St. Kitts and Nevis in 1995 to that in 1996?
Offer a very short reply. 0.9. What is the ratio of the Agriculture value added per worker (constant 2005 US$) of World in 1995 to that in 1997?
Keep it short and to the point. 0.87. What is the ratio of the Agriculture value added per worker (constant 2005 US$) in Solomon Islands in 1995 to that in 1997?
Your response must be concise. 1.08. What is the ratio of the Agriculture value added per worker (constant 2005 US$) in St. Kitts and Nevis in 1995 to that in 1997?
Give a very brief answer. 0.88. What is the ratio of the Agriculture value added per worker (constant 2005 US$) in World in 1996 to that in 1997?
Give a very brief answer. 0.91. What is the ratio of the Agriculture value added per worker (constant 2005 US$) in St. Kitts and Nevis in 1996 to that in 1997?
Offer a very short reply. 0.97. What is the difference between the highest and the second highest Agriculture value added per worker (constant 2005 US$) in World?
Your answer should be very brief. 91.13. What is the difference between the highest and the second highest Agriculture value added per worker (constant 2005 US$) in Solomon Islands?
Provide a succinct answer. 83.95. What is the difference between the highest and the second highest Agriculture value added per worker (constant 2005 US$) of St. Kitts and Nevis?
Provide a succinct answer. 64.47. What is the difference between the highest and the lowest Agriculture value added per worker (constant 2005 US$) of World?
Your answer should be very brief. 242.95. What is the difference between the highest and the lowest Agriculture value added per worker (constant 2005 US$) in Solomon Islands?
Your response must be concise. 259.42. What is the difference between the highest and the lowest Agriculture value added per worker (constant 2005 US$) in St. Kitts and Nevis?
Make the answer very short. 319.2. 